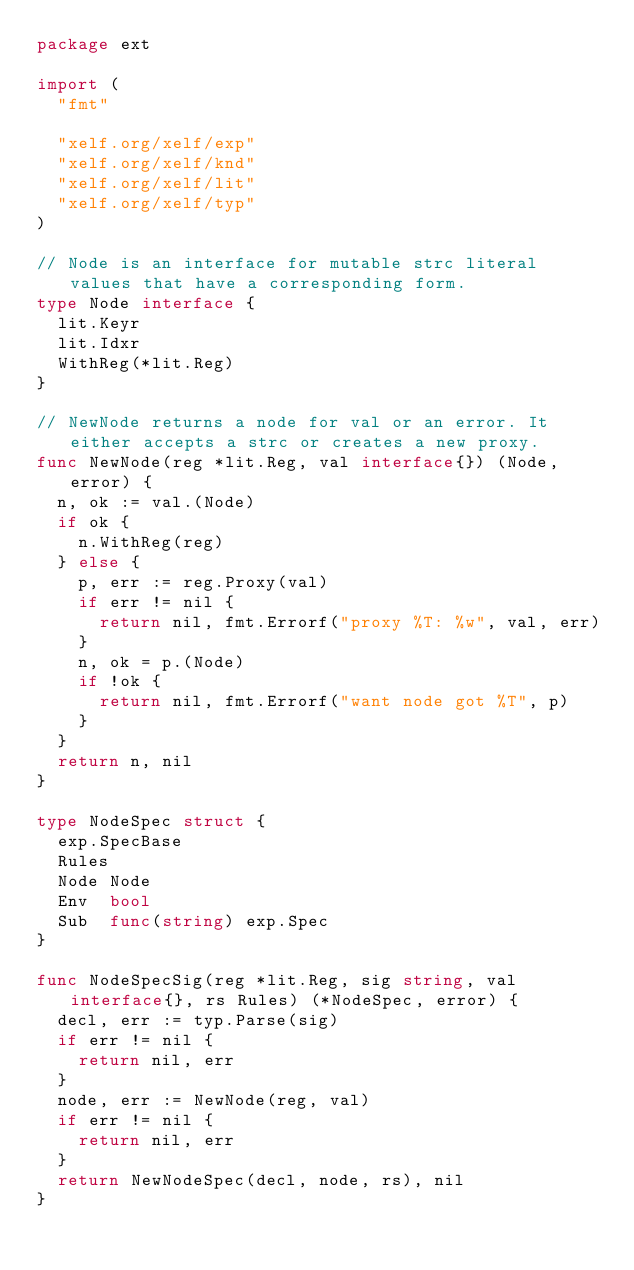Convert code to text. <code><loc_0><loc_0><loc_500><loc_500><_Go_>package ext

import (
	"fmt"

	"xelf.org/xelf/exp"
	"xelf.org/xelf/knd"
	"xelf.org/xelf/lit"
	"xelf.org/xelf/typ"
)

// Node is an interface for mutable strc literal values that have a corresponding form.
type Node interface {
	lit.Keyr
	lit.Idxr
	WithReg(*lit.Reg)
}

// NewNode returns a node for val or an error. It either accepts a strc or creates a new proxy.
func NewNode(reg *lit.Reg, val interface{}) (Node, error) {
	n, ok := val.(Node)
	if ok {
		n.WithReg(reg)
	} else {
		p, err := reg.Proxy(val)
		if err != nil {
			return nil, fmt.Errorf("proxy %T: %w", val, err)
		}
		n, ok = p.(Node)
		if !ok {
			return nil, fmt.Errorf("want node got %T", p)
		}
	}
	return n, nil
}

type NodeSpec struct {
	exp.SpecBase
	Rules
	Node Node
	Env  bool
	Sub  func(string) exp.Spec
}

func NodeSpecSig(reg *lit.Reg, sig string, val interface{}, rs Rules) (*NodeSpec, error) {
	decl, err := typ.Parse(sig)
	if err != nil {
		return nil, err
	}
	node, err := NewNode(reg, val)
	if err != nil {
		return nil, err
	}
	return NewNodeSpec(decl, node, rs), nil
}
</code> 